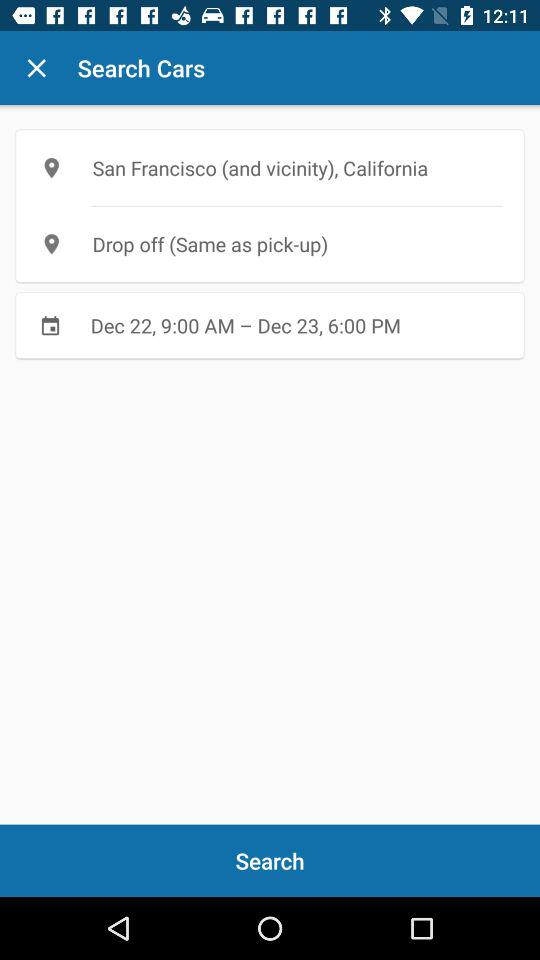What is the given range of date and time? The given range of date and time is December 22, 9:00 AM - December 23, 6:00 PM. 